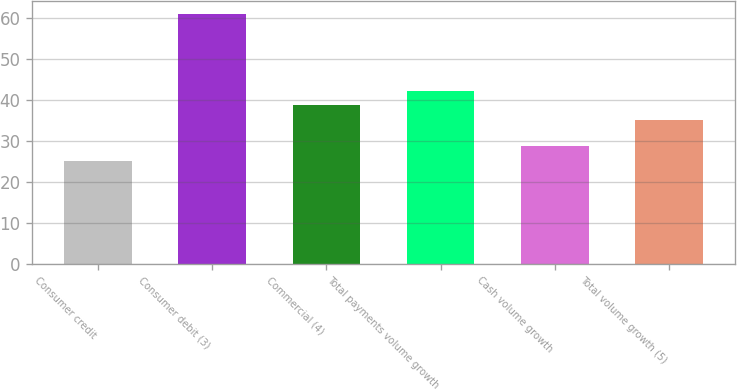Convert chart. <chart><loc_0><loc_0><loc_500><loc_500><bar_chart><fcel>Consumer credit<fcel>Consumer debit (3)<fcel>Commercial (4)<fcel>Total payments volume growth<fcel>Cash volume growth<fcel>Total volume growth (5)<nl><fcel>25<fcel>61<fcel>38.6<fcel>42.2<fcel>28.6<fcel>35<nl></chart> 